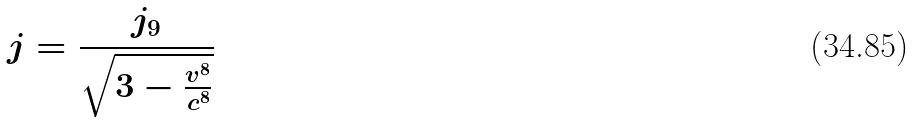<formula> <loc_0><loc_0><loc_500><loc_500>j = \frac { j _ { 9 } } { \sqrt { 3 - \frac { v ^ { 8 } } { c ^ { 8 } } } }</formula> 